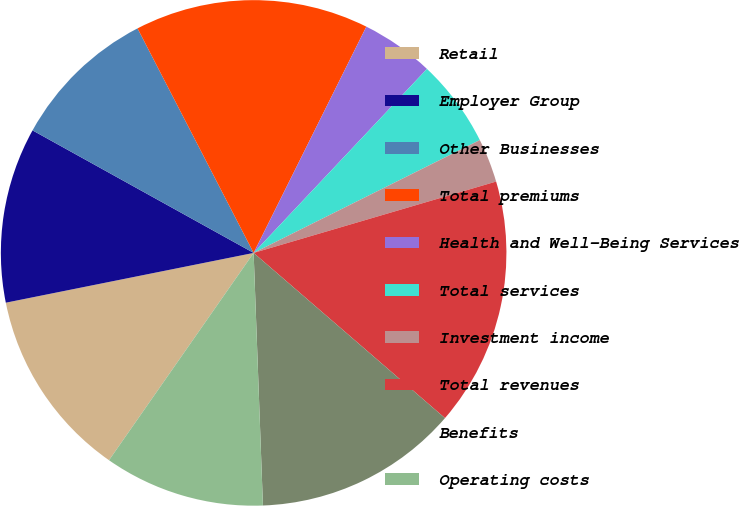Convert chart. <chart><loc_0><loc_0><loc_500><loc_500><pie_chart><fcel>Retail<fcel>Employer Group<fcel>Other Businesses<fcel>Total premiums<fcel>Health and Well-Being Services<fcel>Total services<fcel>Investment income<fcel>Total revenues<fcel>Benefits<fcel>Operating costs<nl><fcel>12.15%<fcel>11.21%<fcel>9.35%<fcel>14.95%<fcel>4.67%<fcel>5.61%<fcel>2.81%<fcel>15.89%<fcel>13.08%<fcel>10.28%<nl></chart> 